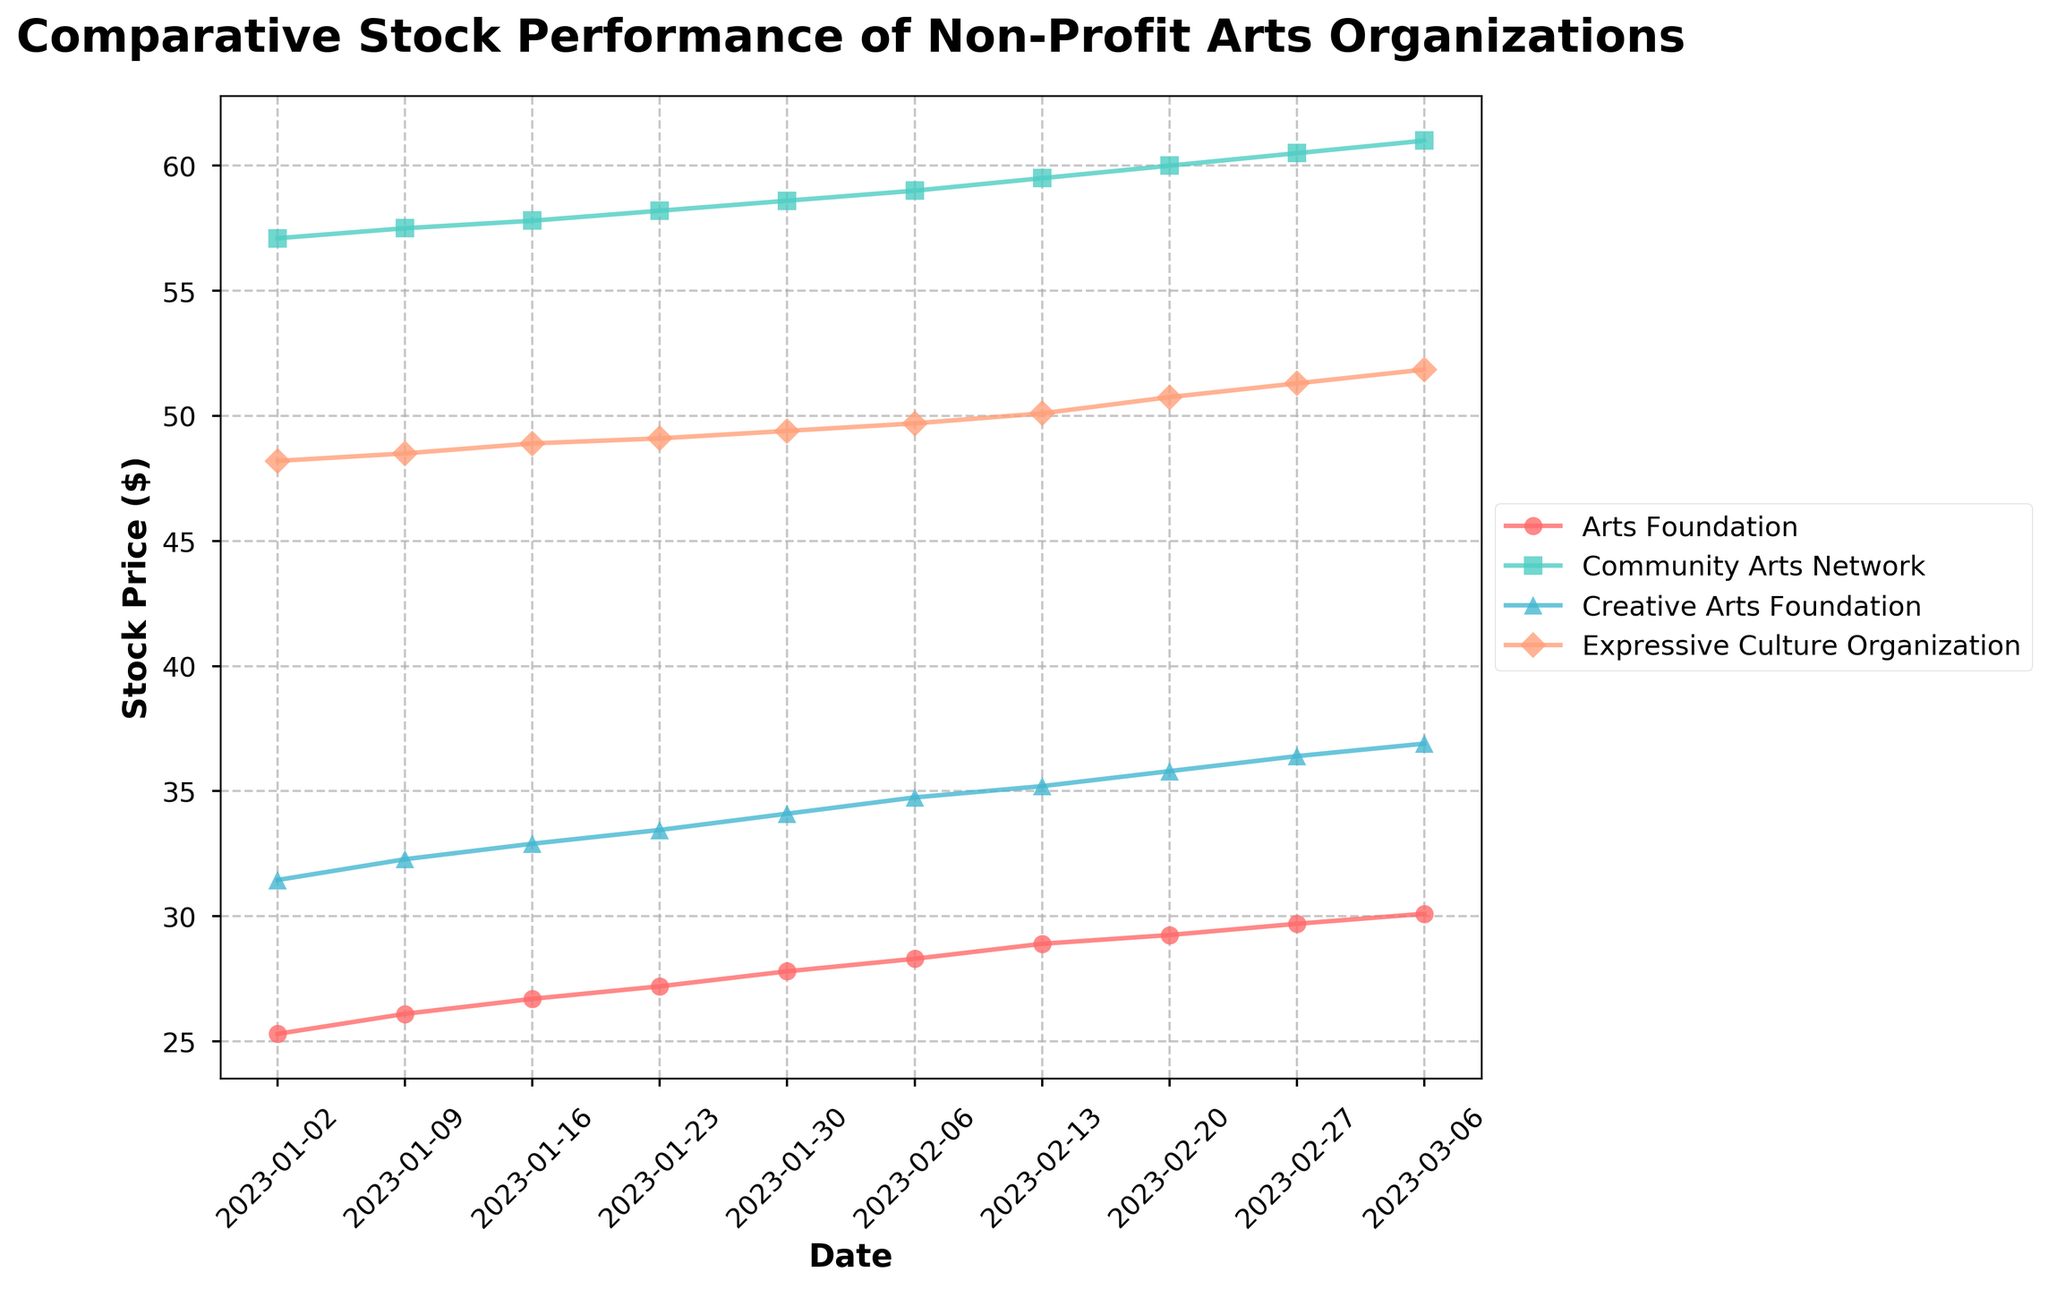What's the title of the plot? The title of the plot is displayed at the top of the figure in a larger, bold font.
Answer: Comparative Stock Performance of Non-Profit Arts Organizations Which stock price started the highest on January 2, 2023? By examining the values on January 2, 2023, "Community Arts Network" has the highest stock price at 57.10.
Answer: Community Arts Network What is the overall trend of the "Arts Foundation" stock price from January to March 2023? The "Arts Foundation" stock price consistently increases from 25.30 on January 2, 2023, to 30.10 on March 6, 2023, indicating an upward trend.
Answer: Upward trend What is the difference in stock price of the "Creative Arts Foundation" between January 16, 2023, and February 13, 2023? The stock price on January 16 is 32.90 and on February 13 is 35.20, the difference is 35.20 - 32.90 = 2.30.
Answer: 2.30 Which organization's stock price shows the least fluctuation over the period? By visual inspection, "Expressive Culture Organization" has the most consistent, least fluctuating trend during the period.
Answer: Expressive Culture Organization By how much did the "Community Arts Network" stock price grow from January 2, 2023, to March 6, 2023? The stock price of "Community Arts Network" on January 2, 2023, was 57.10 and on March 6, 2023, it was 61.00. The growth is 61.00 - 57.10 = 3.90.
Answer: 3.90 What is the highest stock price reached by the "Creative Arts Foundation" during the given period? The highest stock price reached by the "Creative Arts Foundation" is 36.90 on March 6, 2023.
Answer: 36.90 Which organization had the highest stock price on February 27, 2023? On February 27, 2023, the highest stock price is for "Community Arts Network" at 60.50.
Answer: Community Arts Network How does the stock price of "Expressive Culture Organization" on February 13, 2023, compare to its price on February 27, 2023? The stock price of "Expressive Culture Organization" on February 13, 2023, was 50.10 and on February 27, 2023, it was 51.30. Comparing both, the price increased by 51.30 - 50.10 = 1.20.
Answer: Increased by 1.20 